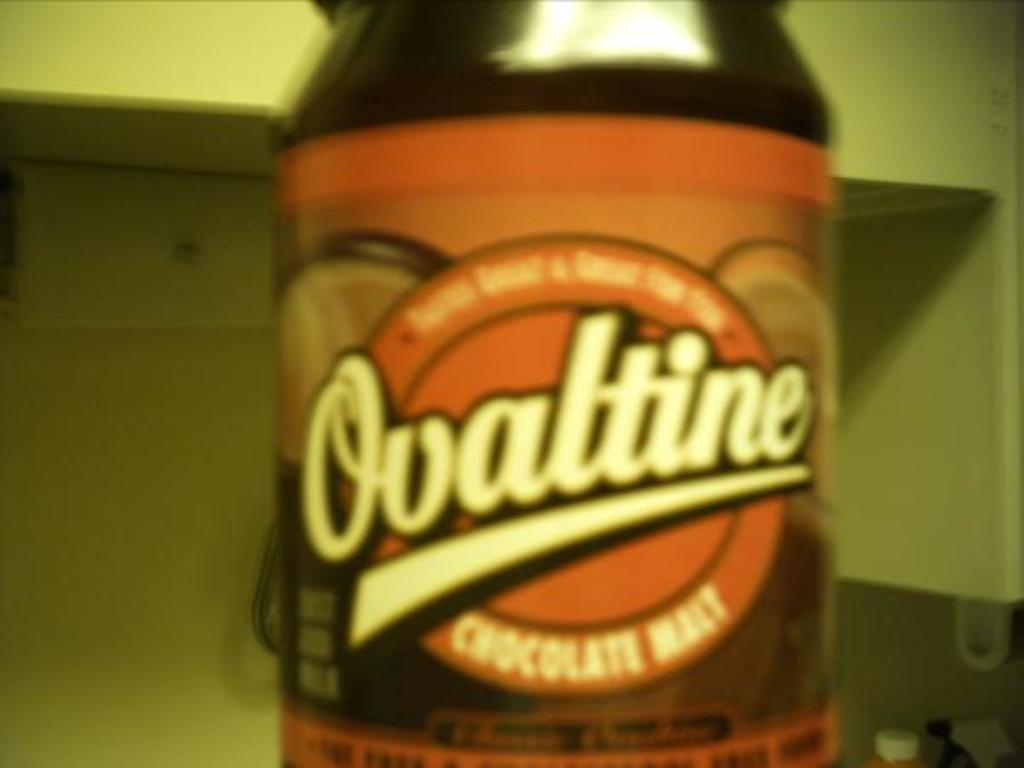Provide a one-sentence caption for the provided image. A chocolate flavored condiment from the brand Ovaltine is in the kitchen. 